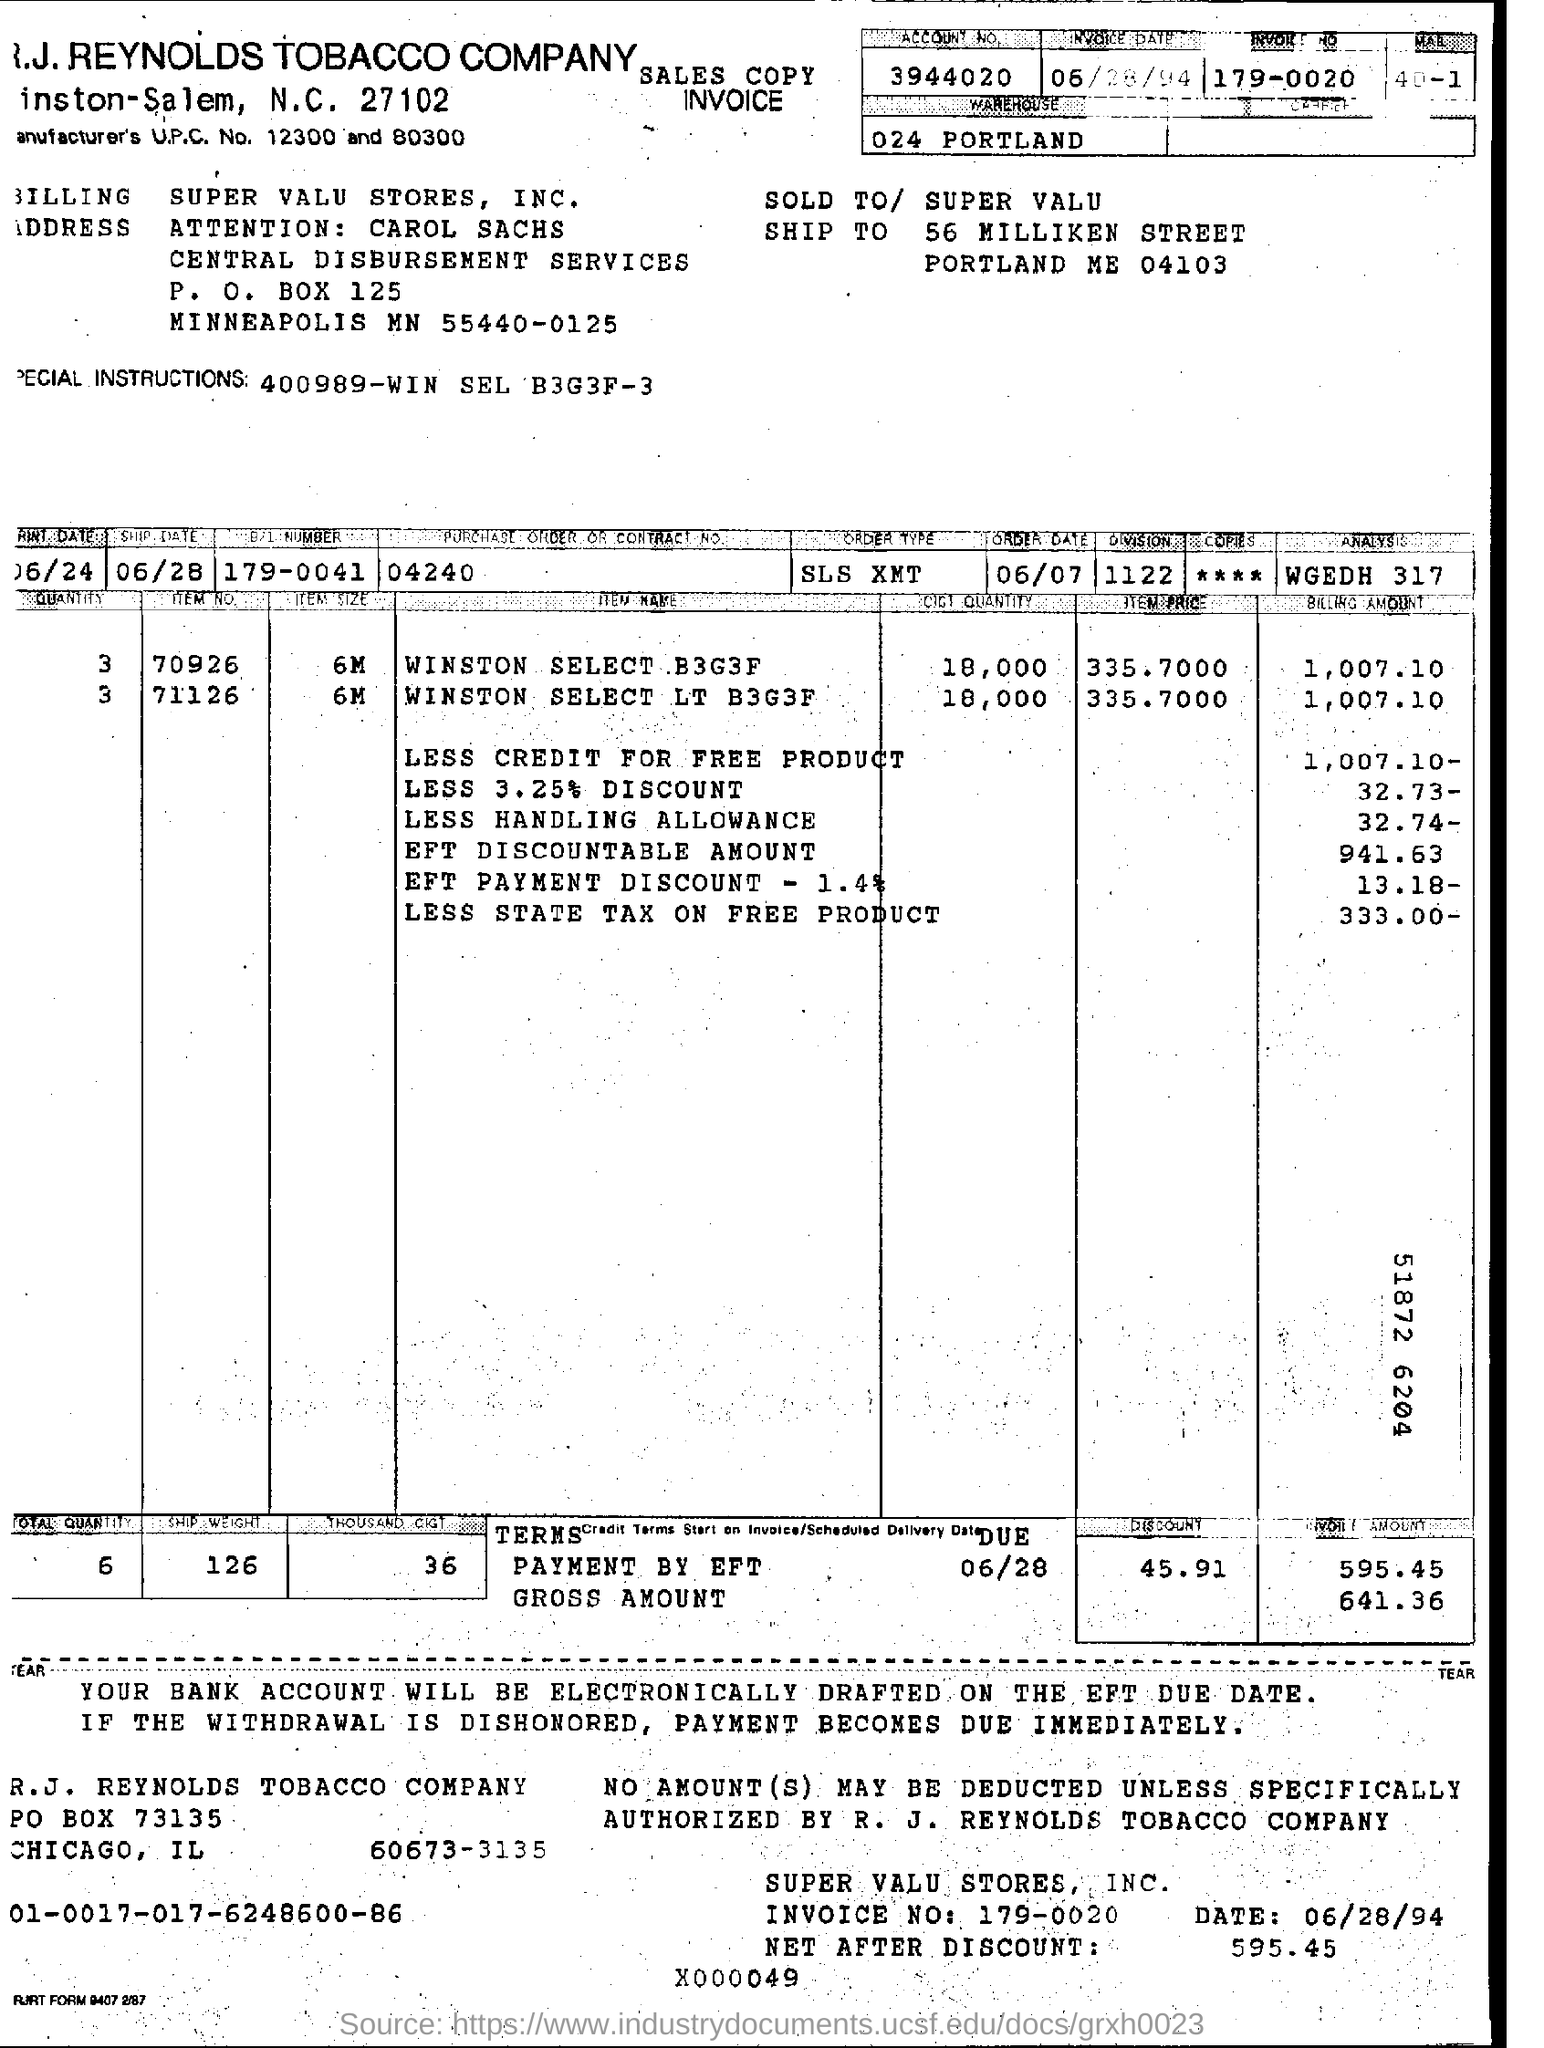Specify some key components in this picture. The account number is 3944020... The price of the Winston select LT B3G3F item is 335.7000. What are the special instructions? 400989-WIN SEL B3G3F-3" is a question asking for information about any specific instructions or requirements that may be necessary for a particular situation or task. A discount of 3.25% will be applied to 32.73% of the billing amount. 